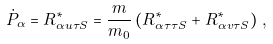Convert formula to latex. <formula><loc_0><loc_0><loc_500><loc_500>\dot { P } _ { \alpha } = R ^ { * } _ { \alpha u \tau S } = \frac { m } { m _ { 0 } } \left ( R ^ { * } _ { \alpha \tau \tau S } + R ^ { * } _ { \alpha v \tau S } \right ) \, ,</formula> 